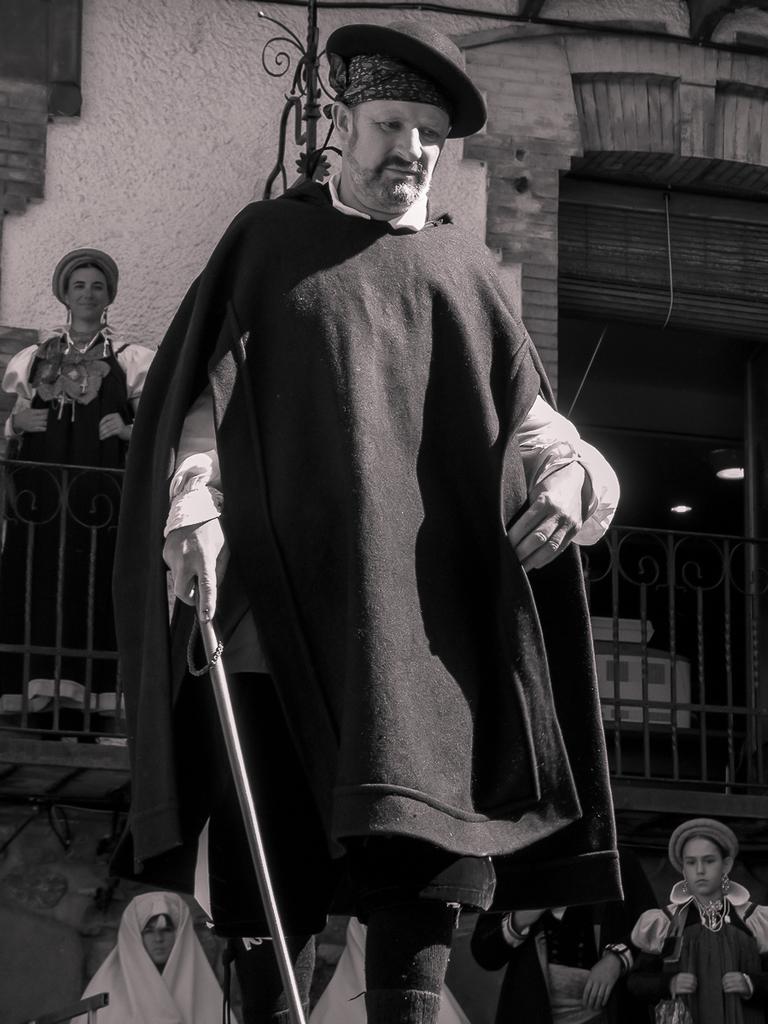Describe this image in one or two sentences. In this image we can see a person holding an object and wearing a hat. There is a person at the left side of the image. There are few people at the bottom of the image. There are few lights at the right side of the image. There is a building in the image. 